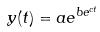<formula> <loc_0><loc_0><loc_500><loc_500>y ( t ) = a e ^ { b e ^ { c t } }</formula> 